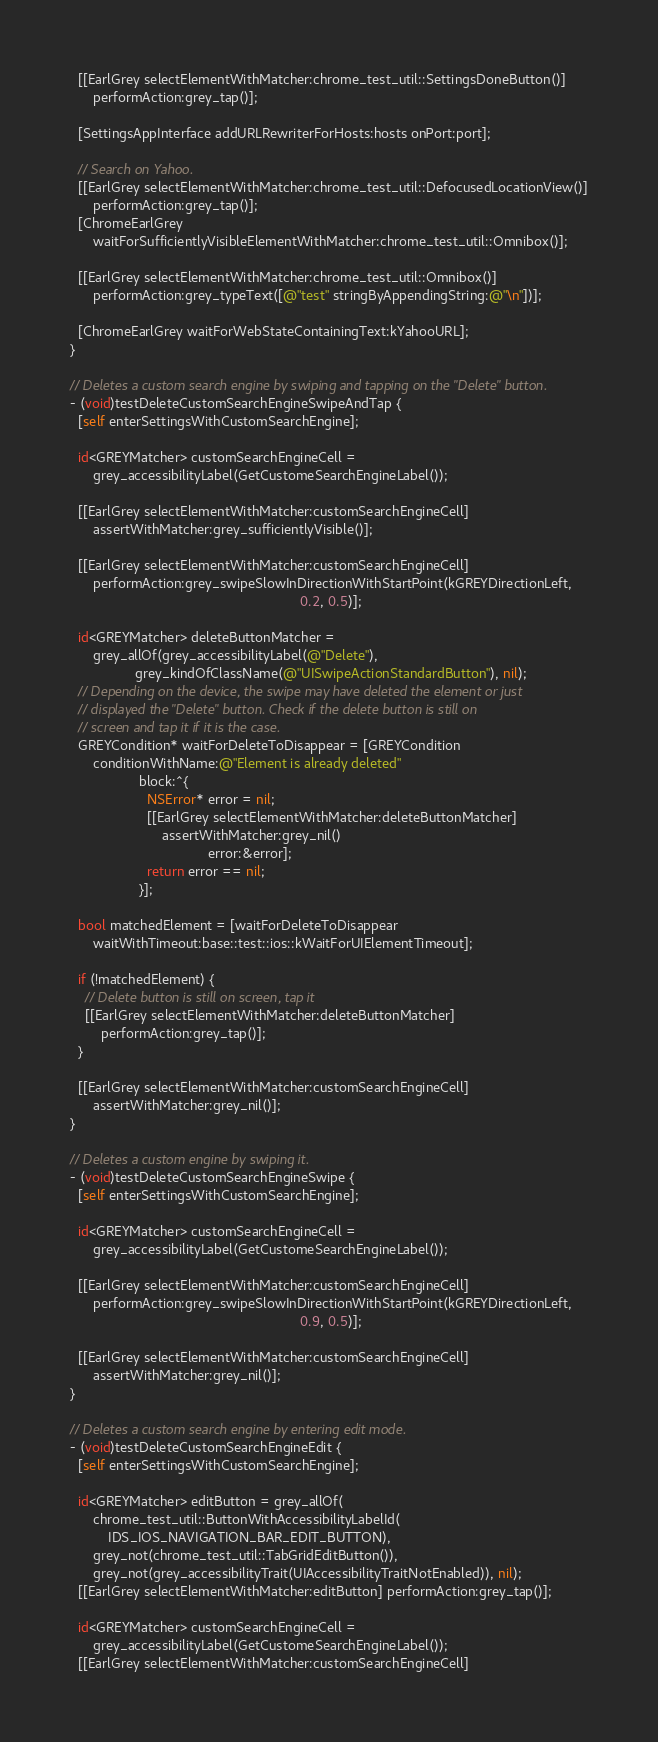Convert code to text. <code><loc_0><loc_0><loc_500><loc_500><_ObjectiveC_>  [[EarlGrey selectElementWithMatcher:chrome_test_util::SettingsDoneButton()]
      performAction:grey_tap()];

  [SettingsAppInterface addURLRewriterForHosts:hosts onPort:port];

  // Search on Yahoo.
  [[EarlGrey selectElementWithMatcher:chrome_test_util::DefocusedLocationView()]
      performAction:grey_tap()];
  [ChromeEarlGrey
      waitForSufficientlyVisibleElementWithMatcher:chrome_test_util::Omnibox()];

  [[EarlGrey selectElementWithMatcher:chrome_test_util::Omnibox()]
      performAction:grey_typeText([@"test" stringByAppendingString:@"\n"])];

  [ChromeEarlGrey waitForWebStateContainingText:kYahooURL];
}

// Deletes a custom search engine by swiping and tapping on the "Delete" button.
- (void)testDeleteCustomSearchEngineSwipeAndTap {
  [self enterSettingsWithCustomSearchEngine];

  id<GREYMatcher> customSearchEngineCell =
      grey_accessibilityLabel(GetCustomeSearchEngineLabel());

  [[EarlGrey selectElementWithMatcher:customSearchEngineCell]
      assertWithMatcher:grey_sufficientlyVisible()];

  [[EarlGrey selectElementWithMatcher:customSearchEngineCell]
      performAction:grey_swipeSlowInDirectionWithStartPoint(kGREYDirectionLeft,
                                                            0.2, 0.5)];

  id<GREYMatcher> deleteButtonMatcher =
      grey_allOf(grey_accessibilityLabel(@"Delete"),
                 grey_kindOfClassName(@"UISwipeActionStandardButton"), nil);
  // Depending on the device, the swipe may have deleted the element or just
  // displayed the "Delete" button. Check if the delete button is still on
  // screen and tap it if it is the case.
  GREYCondition* waitForDeleteToDisappear = [GREYCondition
      conditionWithName:@"Element is already deleted"
                  block:^{
                    NSError* error = nil;
                    [[EarlGrey selectElementWithMatcher:deleteButtonMatcher]
                        assertWithMatcher:grey_nil()
                                    error:&error];
                    return error == nil;
                  }];

  bool matchedElement = [waitForDeleteToDisappear
      waitWithTimeout:base::test::ios::kWaitForUIElementTimeout];

  if (!matchedElement) {
    // Delete button is still on screen, tap it
    [[EarlGrey selectElementWithMatcher:deleteButtonMatcher]
        performAction:grey_tap()];
  }

  [[EarlGrey selectElementWithMatcher:customSearchEngineCell]
      assertWithMatcher:grey_nil()];
}

// Deletes a custom engine by swiping it.
- (void)testDeleteCustomSearchEngineSwipe {
  [self enterSettingsWithCustomSearchEngine];

  id<GREYMatcher> customSearchEngineCell =
      grey_accessibilityLabel(GetCustomeSearchEngineLabel());

  [[EarlGrey selectElementWithMatcher:customSearchEngineCell]
      performAction:grey_swipeSlowInDirectionWithStartPoint(kGREYDirectionLeft,
                                                            0.9, 0.5)];

  [[EarlGrey selectElementWithMatcher:customSearchEngineCell]
      assertWithMatcher:grey_nil()];
}

// Deletes a custom search engine by entering edit mode.
- (void)testDeleteCustomSearchEngineEdit {
  [self enterSettingsWithCustomSearchEngine];

  id<GREYMatcher> editButton = grey_allOf(
      chrome_test_util::ButtonWithAccessibilityLabelId(
          IDS_IOS_NAVIGATION_BAR_EDIT_BUTTON),
      grey_not(chrome_test_util::TabGridEditButton()),
      grey_not(grey_accessibilityTrait(UIAccessibilityTraitNotEnabled)), nil);
  [[EarlGrey selectElementWithMatcher:editButton] performAction:grey_tap()];

  id<GREYMatcher> customSearchEngineCell =
      grey_accessibilityLabel(GetCustomeSearchEngineLabel());
  [[EarlGrey selectElementWithMatcher:customSearchEngineCell]</code> 